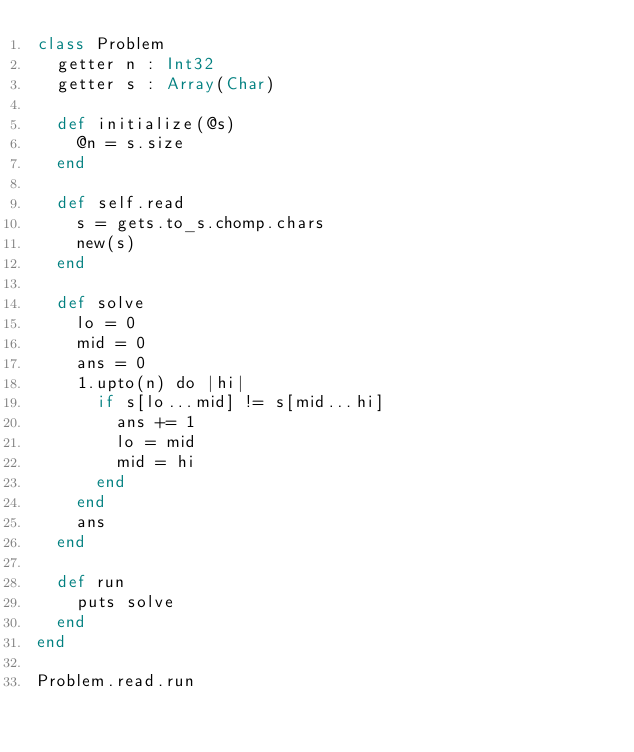<code> <loc_0><loc_0><loc_500><loc_500><_Crystal_>class Problem
  getter n : Int32
  getter s : Array(Char)

  def initialize(@s)
    @n = s.size
  end

  def self.read
    s = gets.to_s.chomp.chars
    new(s)
  end

  def solve
    lo = 0
    mid = 0
    ans = 0
    1.upto(n) do |hi|
      if s[lo...mid] != s[mid...hi]
        ans += 1
        lo = mid
        mid = hi
      end
    end
    ans
  end

  def run
    puts solve
  end
end

Problem.read.run</code> 